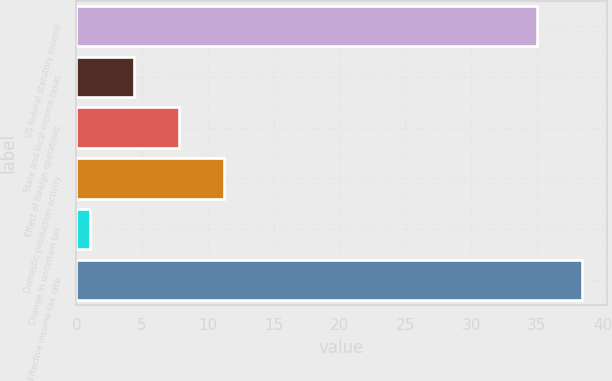Convert chart to OTSL. <chart><loc_0><loc_0><loc_500><loc_500><bar_chart><fcel>US federal statutory income<fcel>State and local income taxes<fcel>Effect of foreign operations<fcel>Domestic production activity<fcel>Change in uncertain tax<fcel>Effective income tax rate<nl><fcel>35<fcel>4.4<fcel>7.8<fcel>11.2<fcel>1<fcel>38.4<nl></chart> 